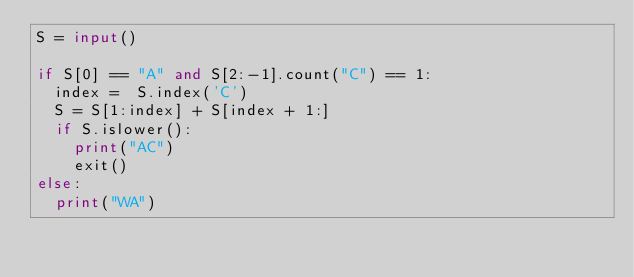Convert code to text. <code><loc_0><loc_0><loc_500><loc_500><_Python_>S = input()

if S[0] == "A" and S[2:-1].count("C") == 1:
  index =  S.index('C')
  S = S[1:index] + S[index + 1:]
  if S.islower():
    print("AC")
    exit()
else:
  print("WA")
</code> 